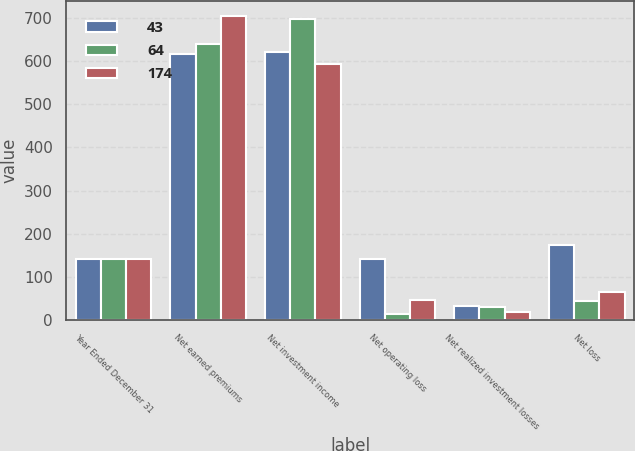Convert chart. <chart><loc_0><loc_0><loc_500><loc_500><stacked_bar_chart><ecel><fcel>Year Ended December 31<fcel>Net earned premiums<fcel>Net investment income<fcel>Net operating loss<fcel>Net realized investment losses<fcel>Net loss<nl><fcel>43<fcel>141<fcel>618<fcel>622<fcel>141<fcel>33<fcel>174<nl><fcel>64<fcel>141<fcel>641<fcel>698<fcel>13<fcel>30<fcel>43<nl><fcel>174<fcel>141<fcel>704<fcel>593<fcel>46<fcel>18<fcel>64<nl></chart> 